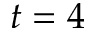<formula> <loc_0><loc_0><loc_500><loc_500>t = 4</formula> 